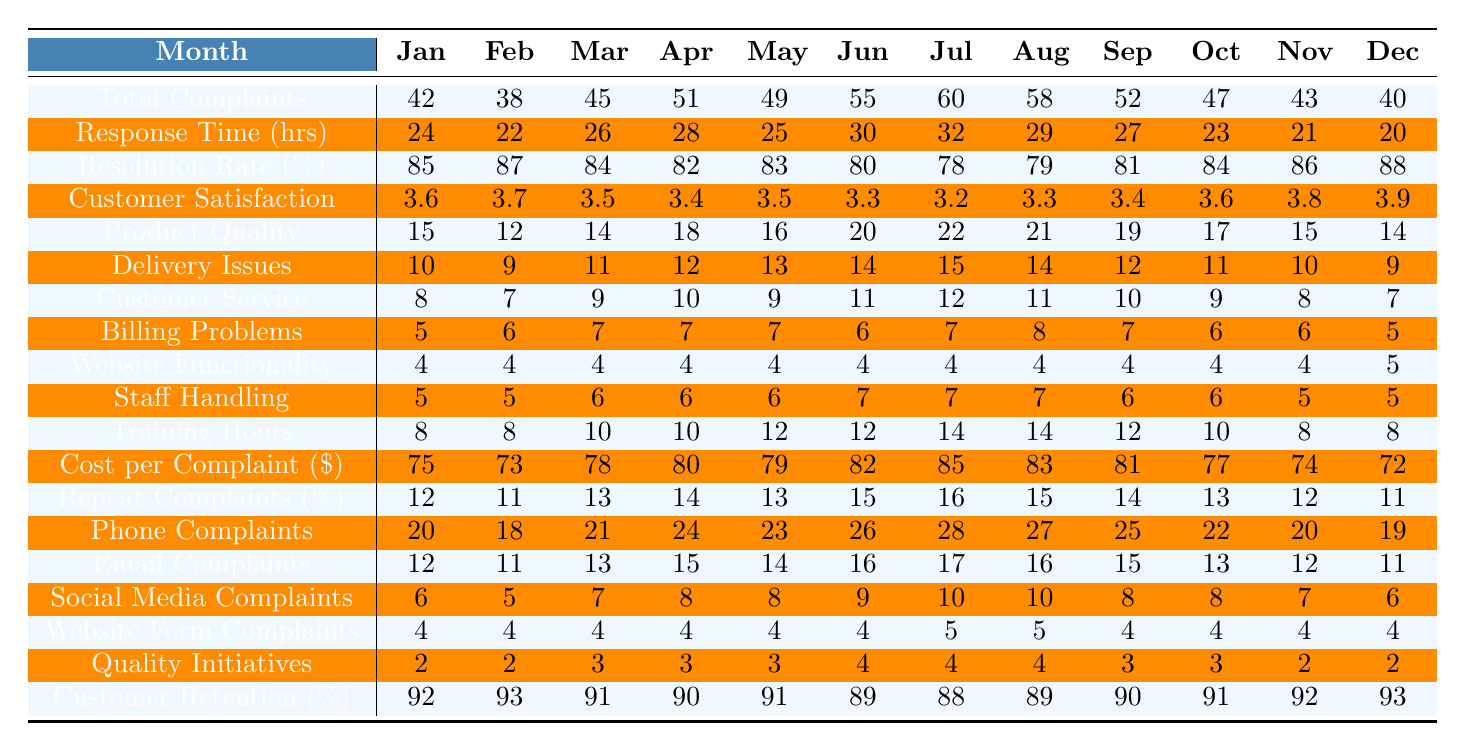What is the highest number of total complaints recorded in a month? By scanning the "Total Complaints" row, the highest value is 60, which is recorded in July.
Answer: 60 What was the resolution rate percentage in December? Looking at the "Resolution Rate (%)" row, the value for December is 88.
Answer: 88 What is the average response time over the 12 months? To find the average response time, sum the values (24 + 22 + 26 + 28 + 25 + 30 + 32 + 29 + 27 + 23 + 21 + 20) =  24 + 22 + 26 + 28 + 25 + 30 + 32 + 29 + 27 + 23 + 21 + 20 = 318 and divide by 12, which gives 318 / 12 = 26.5.
Answer: 26.5 Did the customer satisfaction score ever drop below 3.3? Checking the "Customer Satisfaction" row, the lowest score is 3.2 in July, which confirms that the score did drop below 3.3.
Answer: Yes What is the difference in total complaints between the highest and lowest recorded months? The highest total complaints are 60 in July, and the lowest are 38 in February. Therefore, the difference is 60 - 38 = 22.
Answer: 22 In which month was the highest cost per complaint recorded? From the "Cost per Complaint ($)" row, July has the highest cost at $85.
Answer: July What was the change in customer retention rate from January to June? The retention rate for January is 92%, and for June it is 89%. The change is 89 - 92 = -3%.
Answer: -3% How many complaints were related to website functionality in November? By examining the "Website Functionality" row, the number of complaints in November is 4.
Answer: 4 What were the total complaints from both delivery issues and customer service in August? For August, delivery issues are 14 and customer service complaints are 11. Adding these gives 14 + 11 = 25.
Answer: 25 What is the percentage of repeat complaints for the month with the highest total complaints? The month with the highest total complaints is July, which has a repeat complaint percentage of 16%.
Answer: 16% What is the trend in training hours per staff from January to December? Training hours increased from 8 in January to 8 again in December, peaking at 14 in July and August, thus showing a fluctuating trend with a peak mid-year.
Answer: Fluctuating trend with a peak at mid-year 